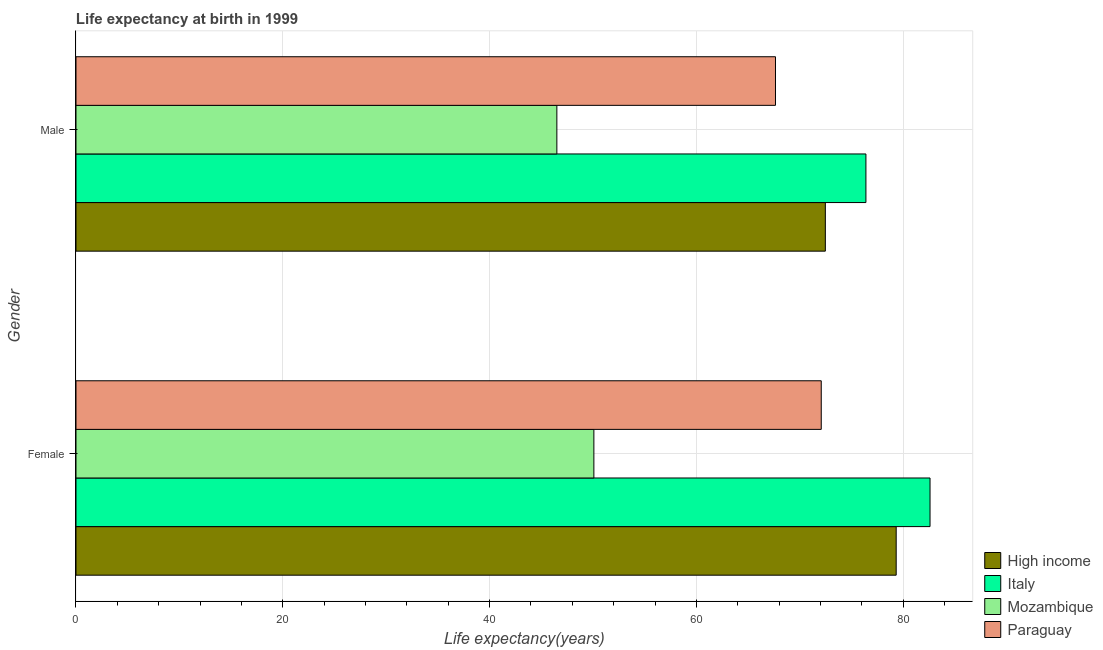How many different coloured bars are there?
Your response must be concise. 4. How many bars are there on the 2nd tick from the top?
Your answer should be compact. 4. What is the life expectancy(female) in Mozambique?
Your answer should be compact. 50.09. Across all countries, what is the maximum life expectancy(female)?
Your answer should be compact. 82.6. Across all countries, what is the minimum life expectancy(male)?
Keep it short and to the point. 46.51. In which country was the life expectancy(female) minimum?
Give a very brief answer. Mozambique. What is the total life expectancy(male) in the graph?
Provide a short and direct response. 263.04. What is the difference between the life expectancy(female) in Mozambique and that in Paraguay?
Offer a very short reply. -21.99. What is the difference between the life expectancy(male) in Italy and the life expectancy(female) in Mozambique?
Your answer should be compact. 26.31. What is the average life expectancy(male) per country?
Provide a succinct answer. 65.76. What is the difference between the life expectancy(male) and life expectancy(female) in High income?
Ensure brevity in your answer.  -6.85. In how many countries, is the life expectancy(female) greater than 28 years?
Provide a short and direct response. 4. What is the ratio of the life expectancy(female) in High income to that in Italy?
Your answer should be very brief. 0.96. Is the life expectancy(female) in High income less than that in Paraguay?
Keep it short and to the point. No. What does the 4th bar from the top in Female represents?
Offer a very short reply. High income. What does the 4th bar from the bottom in Male represents?
Offer a very short reply. Paraguay. Are all the bars in the graph horizontal?
Offer a terse response. Yes. Are the values on the major ticks of X-axis written in scientific E-notation?
Offer a terse response. No. Does the graph contain grids?
Make the answer very short. Yes. Where does the legend appear in the graph?
Your response must be concise. Bottom right. How many legend labels are there?
Your answer should be very brief. 4. What is the title of the graph?
Ensure brevity in your answer.  Life expectancy at birth in 1999. What is the label or title of the X-axis?
Your response must be concise. Life expectancy(years). What is the label or title of the Y-axis?
Your answer should be compact. Gender. What is the Life expectancy(years) in High income in Female?
Your response must be concise. 79.33. What is the Life expectancy(years) of Italy in Female?
Keep it short and to the point. 82.6. What is the Life expectancy(years) of Mozambique in Female?
Provide a succinct answer. 50.09. What is the Life expectancy(years) of Paraguay in Female?
Provide a succinct answer. 72.08. What is the Life expectancy(years) of High income in Male?
Provide a short and direct response. 72.48. What is the Life expectancy(years) of Italy in Male?
Give a very brief answer. 76.4. What is the Life expectancy(years) of Mozambique in Male?
Make the answer very short. 46.51. What is the Life expectancy(years) of Paraguay in Male?
Your answer should be compact. 67.65. Across all Gender, what is the maximum Life expectancy(years) in High income?
Give a very brief answer. 79.33. Across all Gender, what is the maximum Life expectancy(years) in Italy?
Offer a terse response. 82.6. Across all Gender, what is the maximum Life expectancy(years) in Mozambique?
Your answer should be compact. 50.09. Across all Gender, what is the maximum Life expectancy(years) of Paraguay?
Offer a very short reply. 72.08. Across all Gender, what is the minimum Life expectancy(years) in High income?
Provide a short and direct response. 72.48. Across all Gender, what is the minimum Life expectancy(years) of Italy?
Provide a succinct answer. 76.4. Across all Gender, what is the minimum Life expectancy(years) of Mozambique?
Your answer should be very brief. 46.51. Across all Gender, what is the minimum Life expectancy(years) of Paraguay?
Your response must be concise. 67.65. What is the total Life expectancy(years) in High income in the graph?
Make the answer very short. 151.8. What is the total Life expectancy(years) in Italy in the graph?
Offer a very short reply. 159. What is the total Life expectancy(years) in Mozambique in the graph?
Your answer should be very brief. 96.6. What is the total Life expectancy(years) of Paraguay in the graph?
Offer a terse response. 139.73. What is the difference between the Life expectancy(years) of High income in Female and that in Male?
Keep it short and to the point. 6.85. What is the difference between the Life expectancy(years) in Mozambique in Female and that in Male?
Ensure brevity in your answer.  3.58. What is the difference between the Life expectancy(years) in Paraguay in Female and that in Male?
Your answer should be very brief. 4.42. What is the difference between the Life expectancy(years) of High income in Female and the Life expectancy(years) of Italy in Male?
Ensure brevity in your answer.  2.93. What is the difference between the Life expectancy(years) of High income in Female and the Life expectancy(years) of Mozambique in Male?
Offer a terse response. 32.82. What is the difference between the Life expectancy(years) of High income in Female and the Life expectancy(years) of Paraguay in Male?
Give a very brief answer. 11.67. What is the difference between the Life expectancy(years) in Italy in Female and the Life expectancy(years) in Mozambique in Male?
Provide a succinct answer. 36.09. What is the difference between the Life expectancy(years) in Italy in Female and the Life expectancy(years) in Paraguay in Male?
Make the answer very short. 14.95. What is the difference between the Life expectancy(years) of Mozambique in Female and the Life expectancy(years) of Paraguay in Male?
Offer a terse response. -17.57. What is the average Life expectancy(years) of High income per Gender?
Your response must be concise. 75.9. What is the average Life expectancy(years) of Italy per Gender?
Offer a very short reply. 79.5. What is the average Life expectancy(years) of Mozambique per Gender?
Offer a terse response. 48.3. What is the average Life expectancy(years) of Paraguay per Gender?
Your answer should be very brief. 69.87. What is the difference between the Life expectancy(years) of High income and Life expectancy(years) of Italy in Female?
Ensure brevity in your answer.  -3.27. What is the difference between the Life expectancy(years) of High income and Life expectancy(years) of Mozambique in Female?
Your answer should be very brief. 29.24. What is the difference between the Life expectancy(years) of High income and Life expectancy(years) of Paraguay in Female?
Your answer should be very brief. 7.25. What is the difference between the Life expectancy(years) of Italy and Life expectancy(years) of Mozambique in Female?
Your answer should be compact. 32.51. What is the difference between the Life expectancy(years) in Italy and Life expectancy(years) in Paraguay in Female?
Ensure brevity in your answer.  10.52. What is the difference between the Life expectancy(years) in Mozambique and Life expectancy(years) in Paraguay in Female?
Keep it short and to the point. -21.99. What is the difference between the Life expectancy(years) of High income and Life expectancy(years) of Italy in Male?
Your response must be concise. -3.92. What is the difference between the Life expectancy(years) of High income and Life expectancy(years) of Mozambique in Male?
Your response must be concise. 25.97. What is the difference between the Life expectancy(years) in High income and Life expectancy(years) in Paraguay in Male?
Your answer should be compact. 4.82. What is the difference between the Life expectancy(years) of Italy and Life expectancy(years) of Mozambique in Male?
Ensure brevity in your answer.  29.89. What is the difference between the Life expectancy(years) in Italy and Life expectancy(years) in Paraguay in Male?
Your answer should be very brief. 8.75. What is the difference between the Life expectancy(years) of Mozambique and Life expectancy(years) of Paraguay in Male?
Provide a succinct answer. -21.14. What is the ratio of the Life expectancy(years) in High income in Female to that in Male?
Keep it short and to the point. 1.09. What is the ratio of the Life expectancy(years) of Italy in Female to that in Male?
Your response must be concise. 1.08. What is the ratio of the Life expectancy(years) in Mozambique in Female to that in Male?
Your answer should be very brief. 1.08. What is the ratio of the Life expectancy(years) of Paraguay in Female to that in Male?
Provide a succinct answer. 1.07. What is the difference between the highest and the second highest Life expectancy(years) of High income?
Ensure brevity in your answer.  6.85. What is the difference between the highest and the second highest Life expectancy(years) of Mozambique?
Your answer should be very brief. 3.58. What is the difference between the highest and the second highest Life expectancy(years) of Paraguay?
Give a very brief answer. 4.42. What is the difference between the highest and the lowest Life expectancy(years) in High income?
Offer a terse response. 6.85. What is the difference between the highest and the lowest Life expectancy(years) in Mozambique?
Offer a terse response. 3.58. What is the difference between the highest and the lowest Life expectancy(years) in Paraguay?
Your response must be concise. 4.42. 